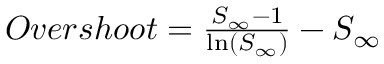<formula> <loc_0><loc_0><loc_500><loc_500>\begin{array} { r } { O v e r s h o o t = \frac { S _ { \infty } - 1 } { \ln ( S _ { \infty } ) } - S _ { \infty } } \end{array}</formula> 